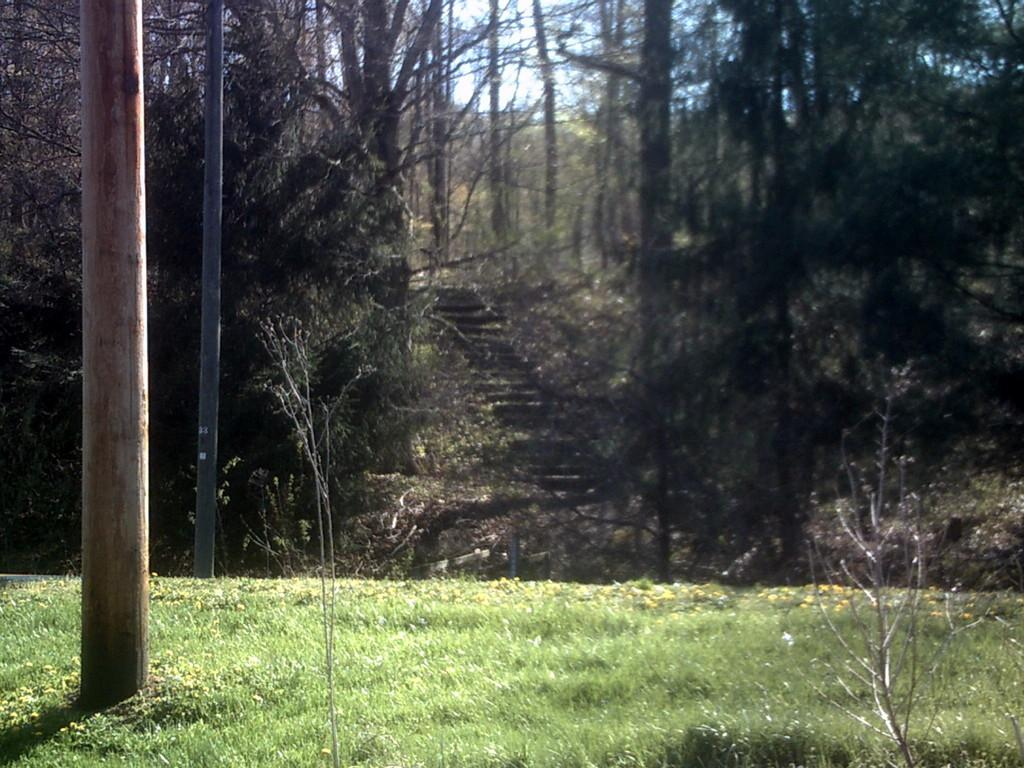What type of vegetation is in the foreground of the image? There is grass in the foreground of the image. What can be seen on the left side of the image? There is a tree trunk on the left side of the image. What is visible in the background of the image? There are trees visible in the background of the image. Can you see a nest in the tree trunk on the left side of the image? There is no nest visible in the tree trunk on the left side of the image. What type of game is being played in the background of the image? There is no game being played in the image; it only features grass, a tree trunk, and trees. 